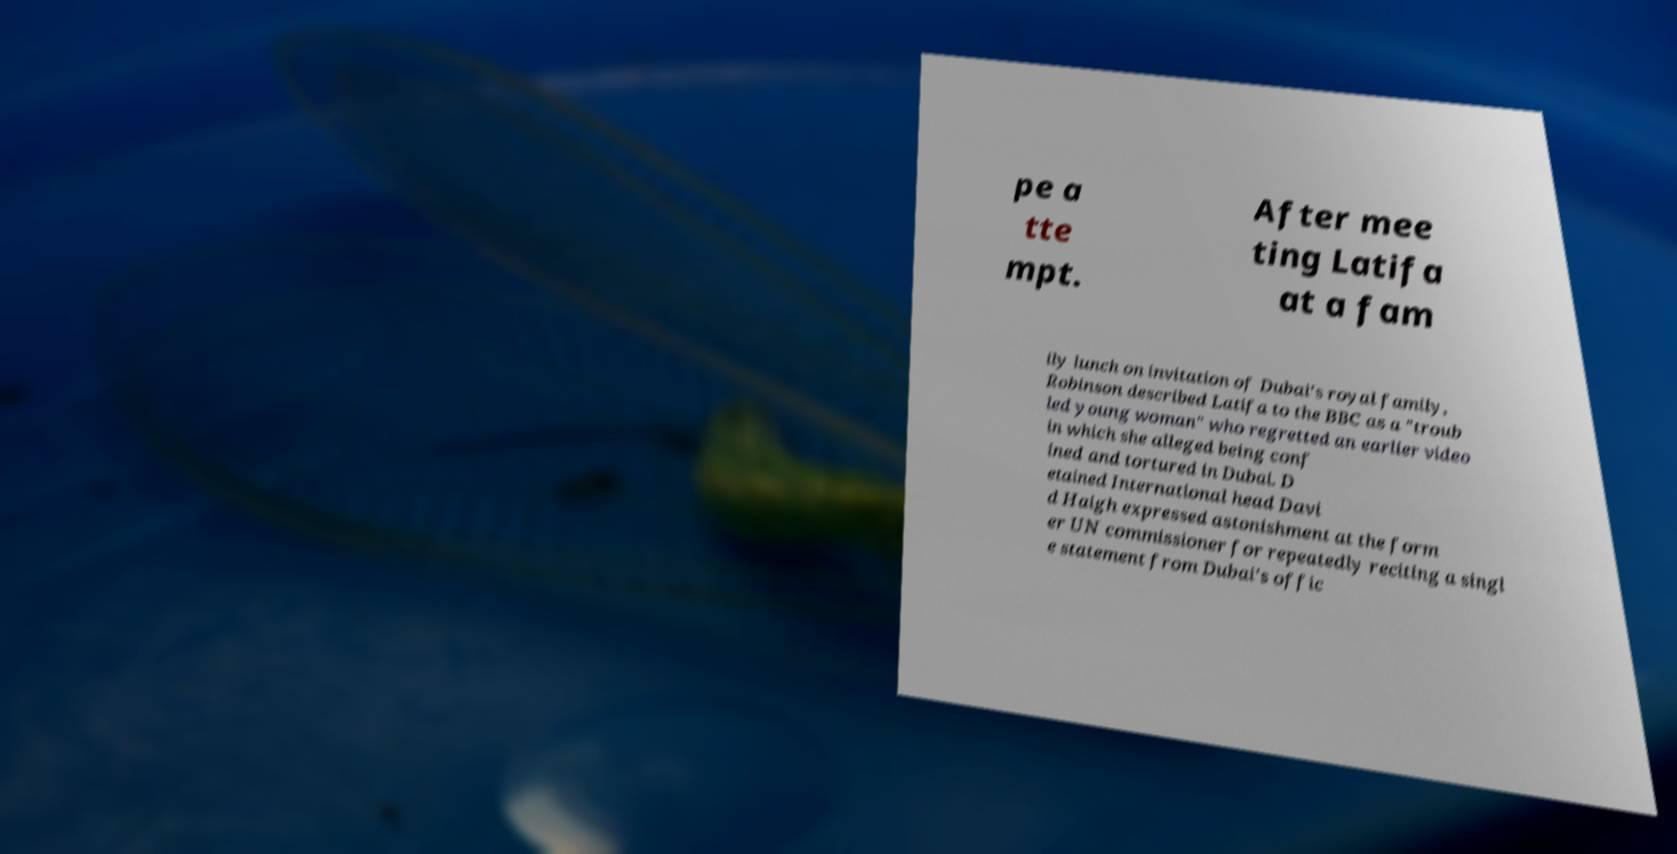I need the written content from this picture converted into text. Can you do that? pe a tte mpt. After mee ting Latifa at a fam ily lunch on invitation of Dubai's royal family, Robinson described Latifa to the BBC as a "troub led young woman" who regretted an earlier video in which she alleged being conf ined and tortured in Dubai. D etained International head Davi d Haigh expressed astonishment at the form er UN commissioner for repeatedly reciting a singl e statement from Dubai's offic 